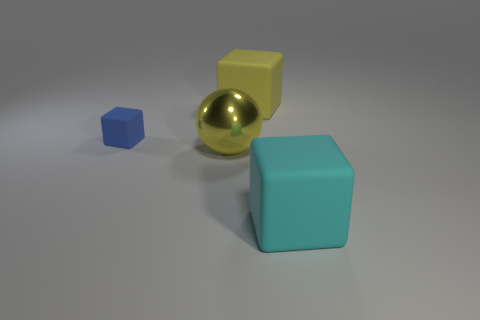What number of things are small objects or small brown balls? In the image, I can see a total of four objects, but none of them are small brown balls. We have a small blue cube, a small shiny gold sphere, a medium yellow cube, and a large teal cube. 